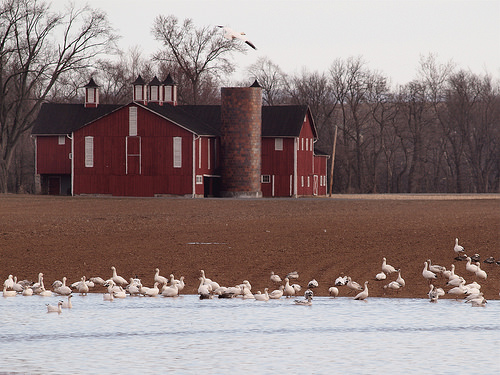<image>
Can you confirm if the bird is above the water? No. The bird is not positioned above the water. The vertical arrangement shows a different relationship. 